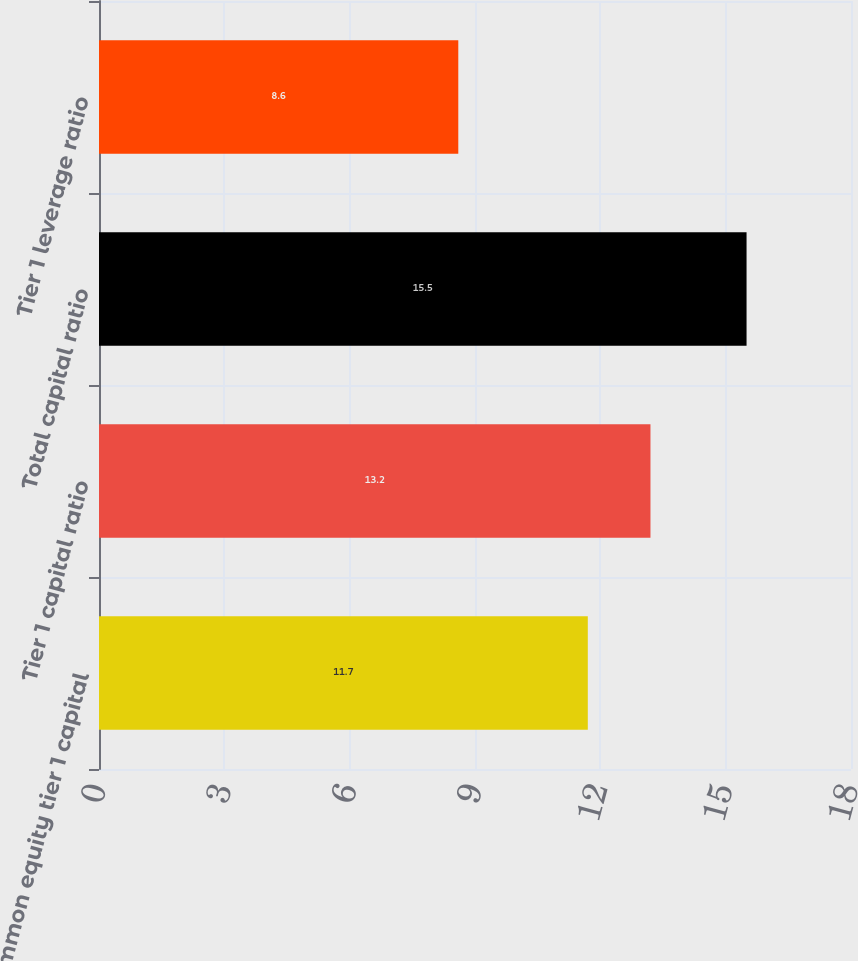Convert chart. <chart><loc_0><loc_0><loc_500><loc_500><bar_chart><fcel>Common equity tier 1 capital<fcel>Tier 1 capital ratio<fcel>Total capital ratio<fcel>Tier 1 leverage ratio<nl><fcel>11.7<fcel>13.2<fcel>15.5<fcel>8.6<nl></chart> 